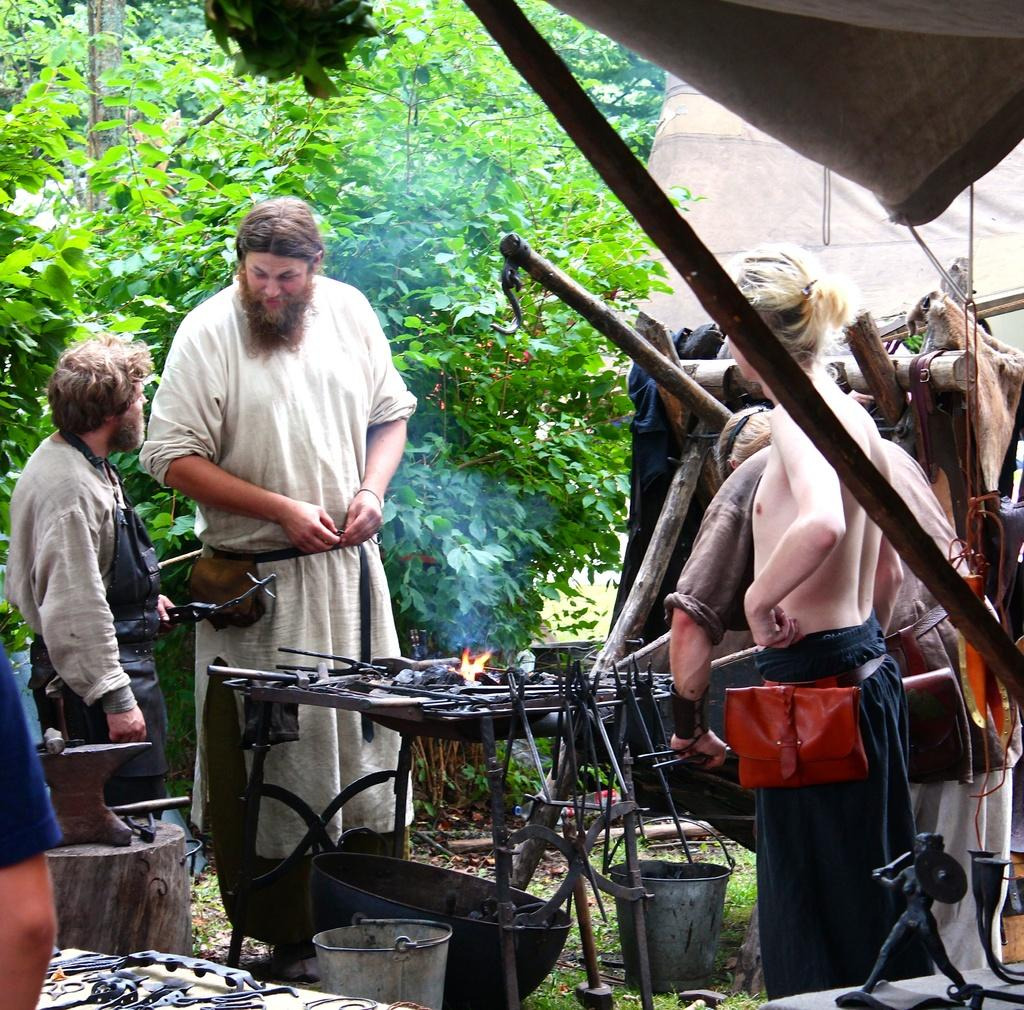What is happening in the image? There are people standing in the image. What can be seen in the background of the image? There are many trees visible in the background of the image. What type of paper is being used by the people in the image? There is no paper visible in the image; the people are simply standing. 